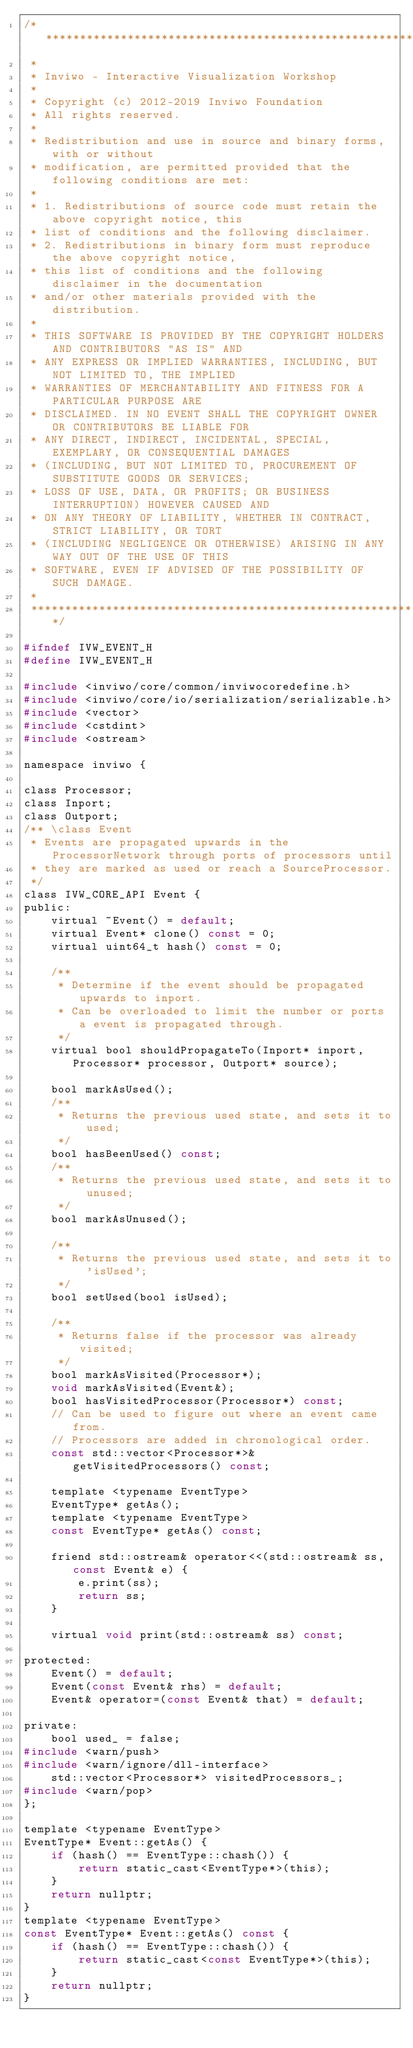<code> <loc_0><loc_0><loc_500><loc_500><_C_>/*********************************************************************************
 *
 * Inviwo - Interactive Visualization Workshop
 *
 * Copyright (c) 2012-2019 Inviwo Foundation
 * All rights reserved.
 *
 * Redistribution and use in source and binary forms, with or without
 * modification, are permitted provided that the following conditions are met:
 *
 * 1. Redistributions of source code must retain the above copyright notice, this
 * list of conditions and the following disclaimer.
 * 2. Redistributions in binary form must reproduce the above copyright notice,
 * this list of conditions and the following disclaimer in the documentation
 * and/or other materials provided with the distribution.
 *
 * THIS SOFTWARE IS PROVIDED BY THE COPYRIGHT HOLDERS AND CONTRIBUTORS "AS IS" AND
 * ANY EXPRESS OR IMPLIED WARRANTIES, INCLUDING, BUT NOT LIMITED TO, THE IMPLIED
 * WARRANTIES OF MERCHANTABILITY AND FITNESS FOR A PARTICULAR PURPOSE ARE
 * DISCLAIMED. IN NO EVENT SHALL THE COPYRIGHT OWNER OR CONTRIBUTORS BE LIABLE FOR
 * ANY DIRECT, INDIRECT, INCIDENTAL, SPECIAL, EXEMPLARY, OR CONSEQUENTIAL DAMAGES
 * (INCLUDING, BUT NOT LIMITED TO, PROCUREMENT OF SUBSTITUTE GOODS OR SERVICES;
 * LOSS OF USE, DATA, OR PROFITS; OR BUSINESS INTERRUPTION) HOWEVER CAUSED AND
 * ON ANY THEORY OF LIABILITY, WHETHER IN CONTRACT, STRICT LIABILITY, OR TORT
 * (INCLUDING NEGLIGENCE OR OTHERWISE) ARISING IN ANY WAY OUT OF THE USE OF THIS
 * SOFTWARE, EVEN IF ADVISED OF THE POSSIBILITY OF SUCH DAMAGE.
 *
 *********************************************************************************/

#ifndef IVW_EVENT_H
#define IVW_EVENT_H

#include <inviwo/core/common/inviwocoredefine.h>
#include <inviwo/core/io/serialization/serializable.h>
#include <vector>
#include <cstdint>
#include <ostream>

namespace inviwo {

class Processor;
class Inport;
class Outport;
/** \class Event
 * Events are propagated upwards in the ProcessorNetwork through ports of processors until
 * they are marked as used or reach a SourceProcessor.
 */
class IVW_CORE_API Event {
public:
    virtual ~Event() = default;
    virtual Event* clone() const = 0;
    virtual uint64_t hash() const = 0;

    /**
     * Determine if the event should be propagated upwards to inport.
     * Can be overloaded to limit the number or ports a event is propagated through.
     */
    virtual bool shouldPropagateTo(Inport* inport, Processor* processor, Outport* source);

    bool markAsUsed();
    /**
     * Returns the previous used state, and sets it to used;
     */
    bool hasBeenUsed() const;
    /**
     * Returns the previous used state, and sets it to unused;
     */
    bool markAsUnused();

    /**
     * Returns the previous used state, and sets it to 'isUsed';
     */
    bool setUsed(bool isUsed);

    /**
     * Returns false if the processor was already visited;
     */
    bool markAsVisited(Processor*);
    void markAsVisited(Event&);
    bool hasVisitedProcessor(Processor*) const;
    // Can be used to figure out where an event came from.
    // Processors are added in chronological order.
    const std::vector<Processor*>& getVisitedProcessors() const;

    template <typename EventType>
    EventType* getAs();
    template <typename EventType>
    const EventType* getAs() const;

    friend std::ostream& operator<<(std::ostream& ss, const Event& e) {
        e.print(ss);
        return ss;
    }

    virtual void print(std::ostream& ss) const;

protected:
    Event() = default;
    Event(const Event& rhs) = default;
    Event& operator=(const Event& that) = default;

private:
    bool used_ = false;
#include <warn/push>
#include <warn/ignore/dll-interface>
    std::vector<Processor*> visitedProcessors_;
#include <warn/pop>
};

template <typename EventType>
EventType* Event::getAs() {
    if (hash() == EventType::chash()) {
        return static_cast<EventType*>(this);
    }
    return nullptr;
}
template <typename EventType>
const EventType* Event::getAs() const {
    if (hash() == EventType::chash()) {
        return static_cast<const EventType*>(this);
    }
    return nullptr;
}
</code> 